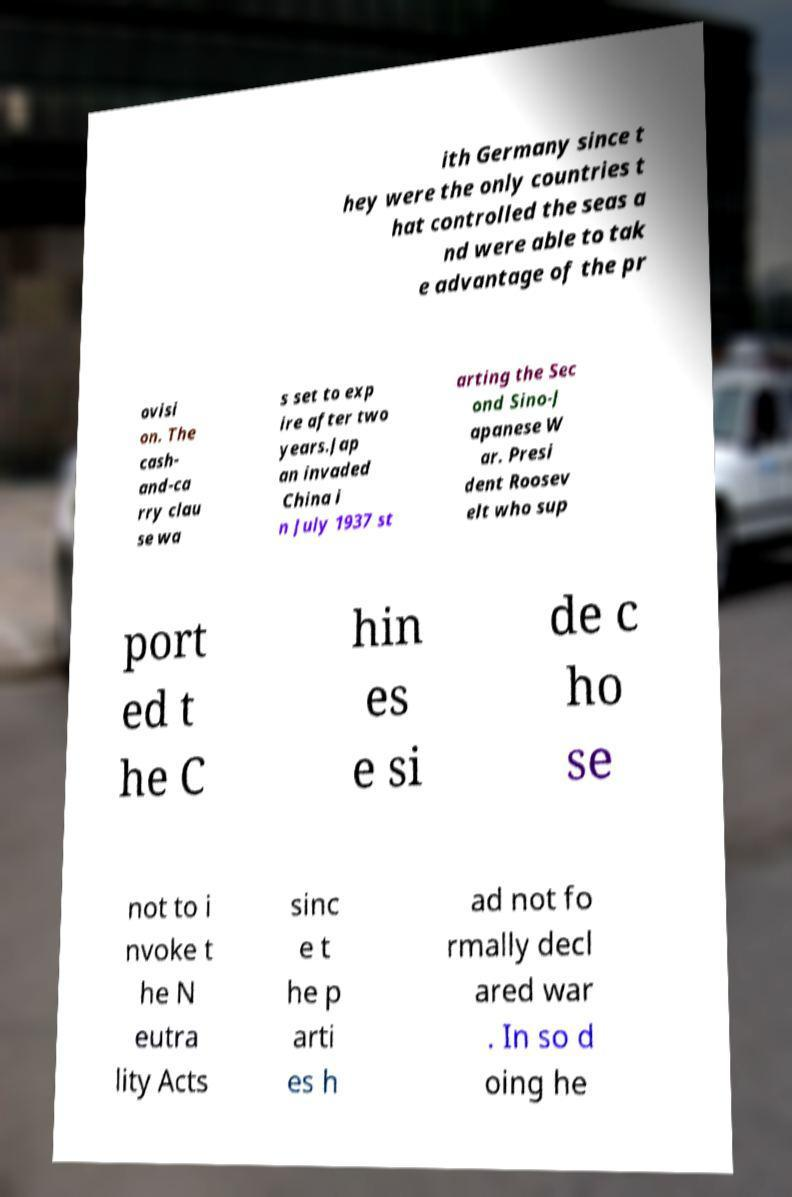Could you extract and type out the text from this image? ith Germany since t hey were the only countries t hat controlled the seas a nd were able to tak e advantage of the pr ovisi on. The cash- and-ca rry clau se wa s set to exp ire after two years.Jap an invaded China i n July 1937 st arting the Sec ond Sino-J apanese W ar. Presi dent Roosev elt who sup port ed t he C hin es e si de c ho se not to i nvoke t he N eutra lity Acts sinc e t he p arti es h ad not fo rmally decl ared war . In so d oing he 